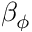<formula> <loc_0><loc_0><loc_500><loc_500>\beta _ { \phi }</formula> 